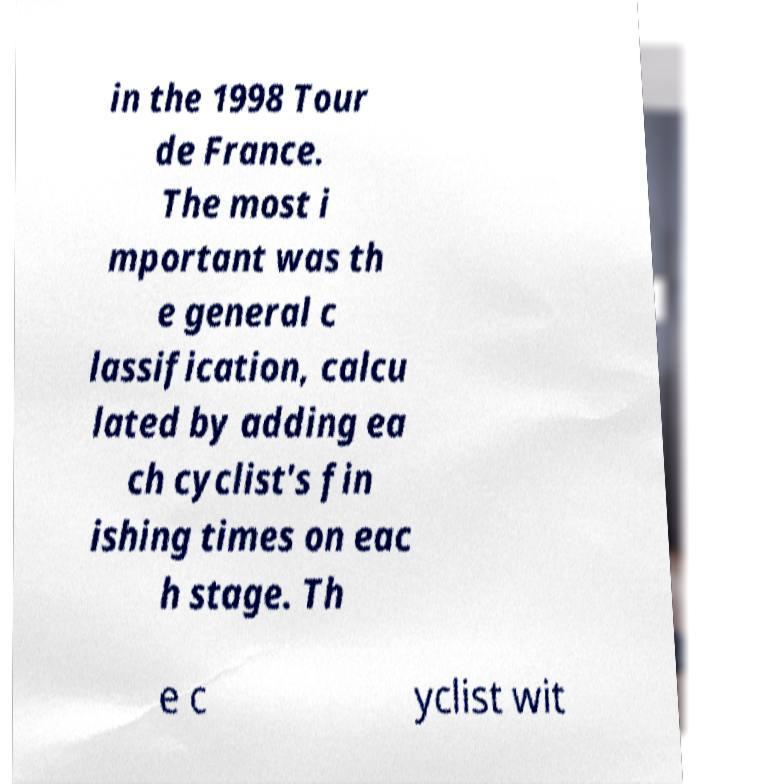Please read and relay the text visible in this image. What does it say? in the 1998 Tour de France. The most i mportant was th e general c lassification, calcu lated by adding ea ch cyclist's fin ishing times on eac h stage. Th e c yclist wit 